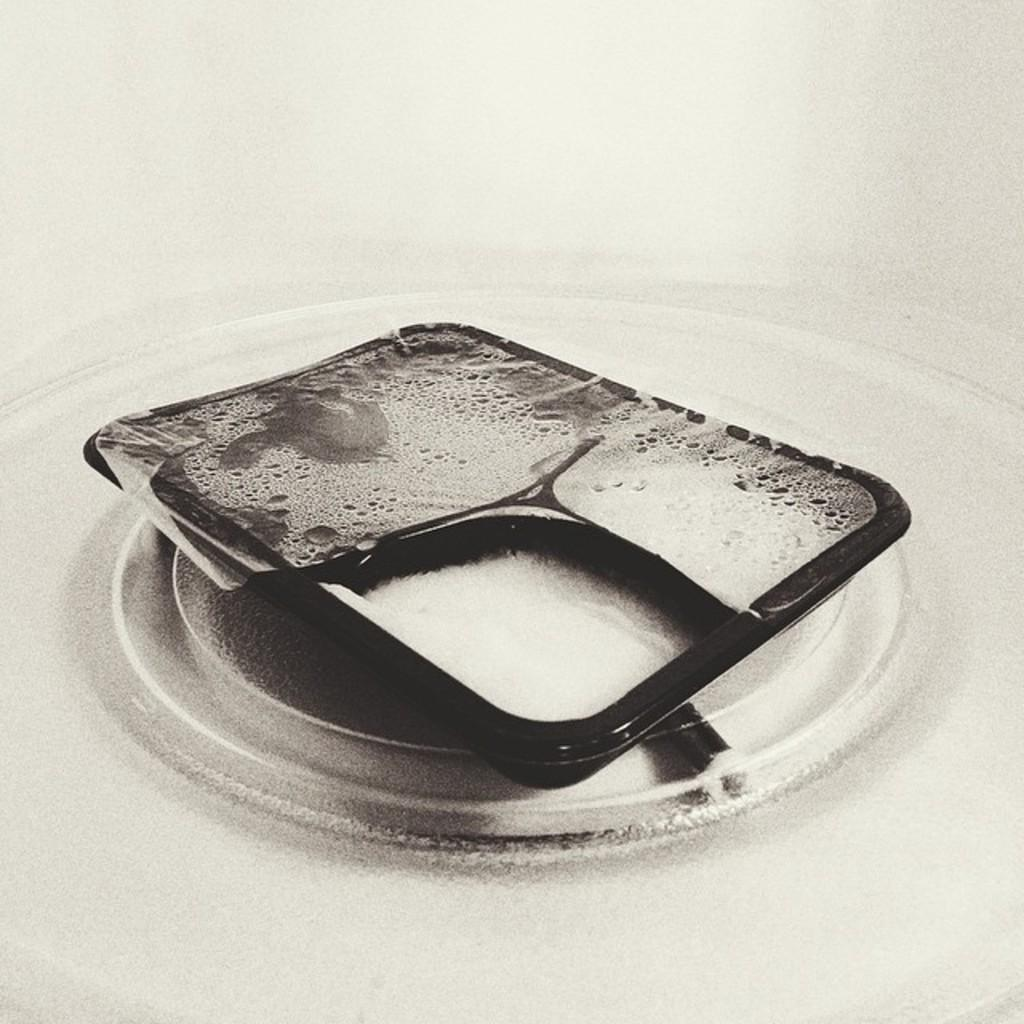What is the color scheme of the image? The image is black and white. What can be seen on the white surface in the image? There is a black object on a white surface in the image. Where is the queen sitting in the image? There is no queen present in the image; it only features a black object on a white surface. What type of cup is being used by the person in the image? There is no person or cup present in the image; it only features a black object on a white surface. 